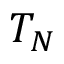Convert formula to latex. <formula><loc_0><loc_0><loc_500><loc_500>T _ { N }</formula> 